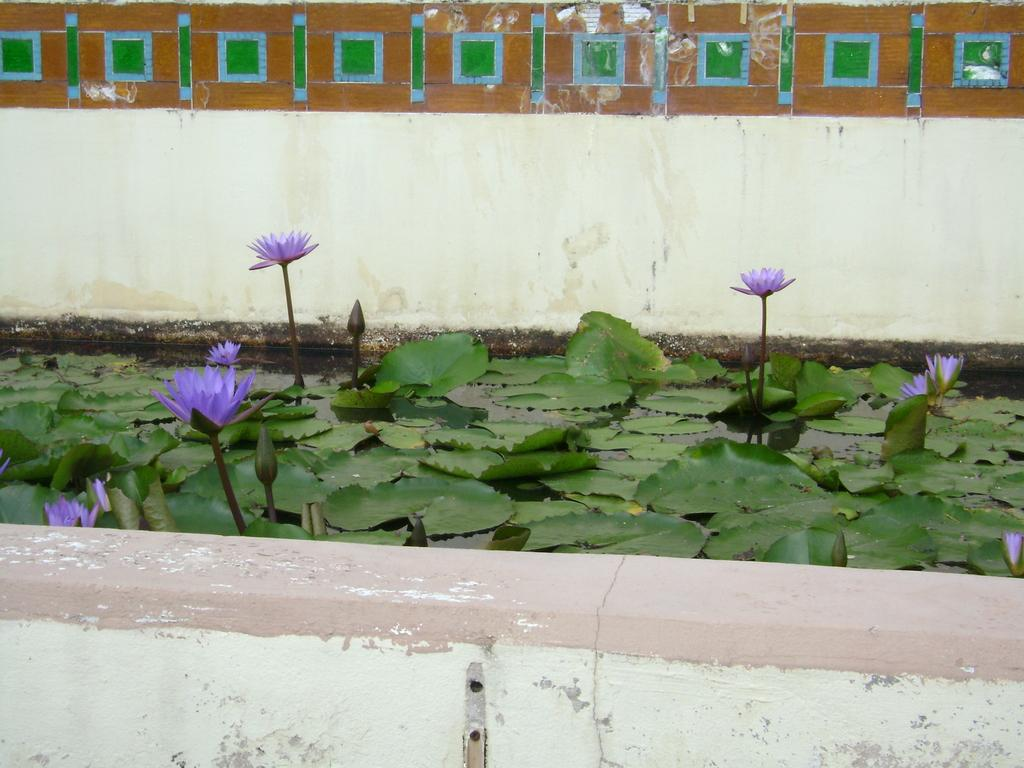What is in the water in the image? There are flowers in the water in the image. What color are the flowers? The flowers are purple. What can be seen in the background of the image? There is a wall visible in the background of the image. How many feet tall is the company in the image? There is no company present in the image, and therefore no height can be determined. 